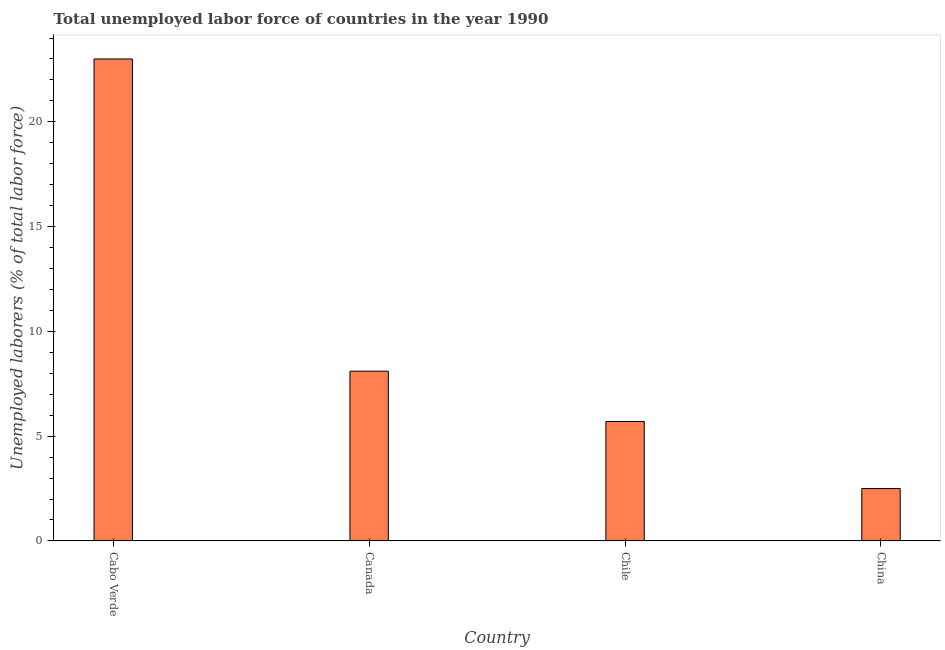What is the title of the graph?
Provide a succinct answer. Total unemployed labor force of countries in the year 1990. What is the label or title of the Y-axis?
Your answer should be very brief. Unemployed laborers (% of total labor force). What is the total unemployed labour force in China?
Your answer should be very brief. 2.5. In which country was the total unemployed labour force maximum?
Keep it short and to the point. Cabo Verde. In which country was the total unemployed labour force minimum?
Your answer should be compact. China. What is the sum of the total unemployed labour force?
Your response must be concise. 39.3. What is the average total unemployed labour force per country?
Make the answer very short. 9.82. What is the median total unemployed labour force?
Your answer should be compact. 6.9. In how many countries, is the total unemployed labour force greater than 19 %?
Offer a terse response. 1. What is the ratio of the total unemployed labour force in Cabo Verde to that in Chile?
Offer a terse response. 4.04. Is the total unemployed labour force in Canada less than that in China?
Provide a short and direct response. No. Is the difference between the total unemployed labour force in Cabo Verde and Chile greater than the difference between any two countries?
Offer a terse response. No. Is the sum of the total unemployed labour force in Cabo Verde and Canada greater than the maximum total unemployed labour force across all countries?
Ensure brevity in your answer.  Yes. Are all the bars in the graph horizontal?
Give a very brief answer. No. How many countries are there in the graph?
Provide a succinct answer. 4. What is the difference between two consecutive major ticks on the Y-axis?
Your answer should be compact. 5. Are the values on the major ticks of Y-axis written in scientific E-notation?
Provide a short and direct response. No. What is the Unemployed laborers (% of total labor force) in Cabo Verde?
Make the answer very short. 23. What is the Unemployed laborers (% of total labor force) of Canada?
Provide a short and direct response. 8.1. What is the Unemployed laborers (% of total labor force) of Chile?
Your answer should be very brief. 5.7. What is the Unemployed laborers (% of total labor force) in China?
Keep it short and to the point. 2.5. What is the difference between the Unemployed laborers (% of total labor force) in Cabo Verde and Canada?
Your response must be concise. 14.9. What is the difference between the Unemployed laborers (% of total labor force) in Canada and Chile?
Offer a very short reply. 2.4. What is the difference between the Unemployed laborers (% of total labor force) in Chile and China?
Your answer should be very brief. 3.2. What is the ratio of the Unemployed laborers (% of total labor force) in Cabo Verde to that in Canada?
Your response must be concise. 2.84. What is the ratio of the Unemployed laborers (% of total labor force) in Cabo Verde to that in Chile?
Give a very brief answer. 4.04. What is the ratio of the Unemployed laborers (% of total labor force) in Canada to that in Chile?
Your answer should be compact. 1.42. What is the ratio of the Unemployed laborers (% of total labor force) in Canada to that in China?
Offer a very short reply. 3.24. What is the ratio of the Unemployed laborers (% of total labor force) in Chile to that in China?
Offer a very short reply. 2.28. 